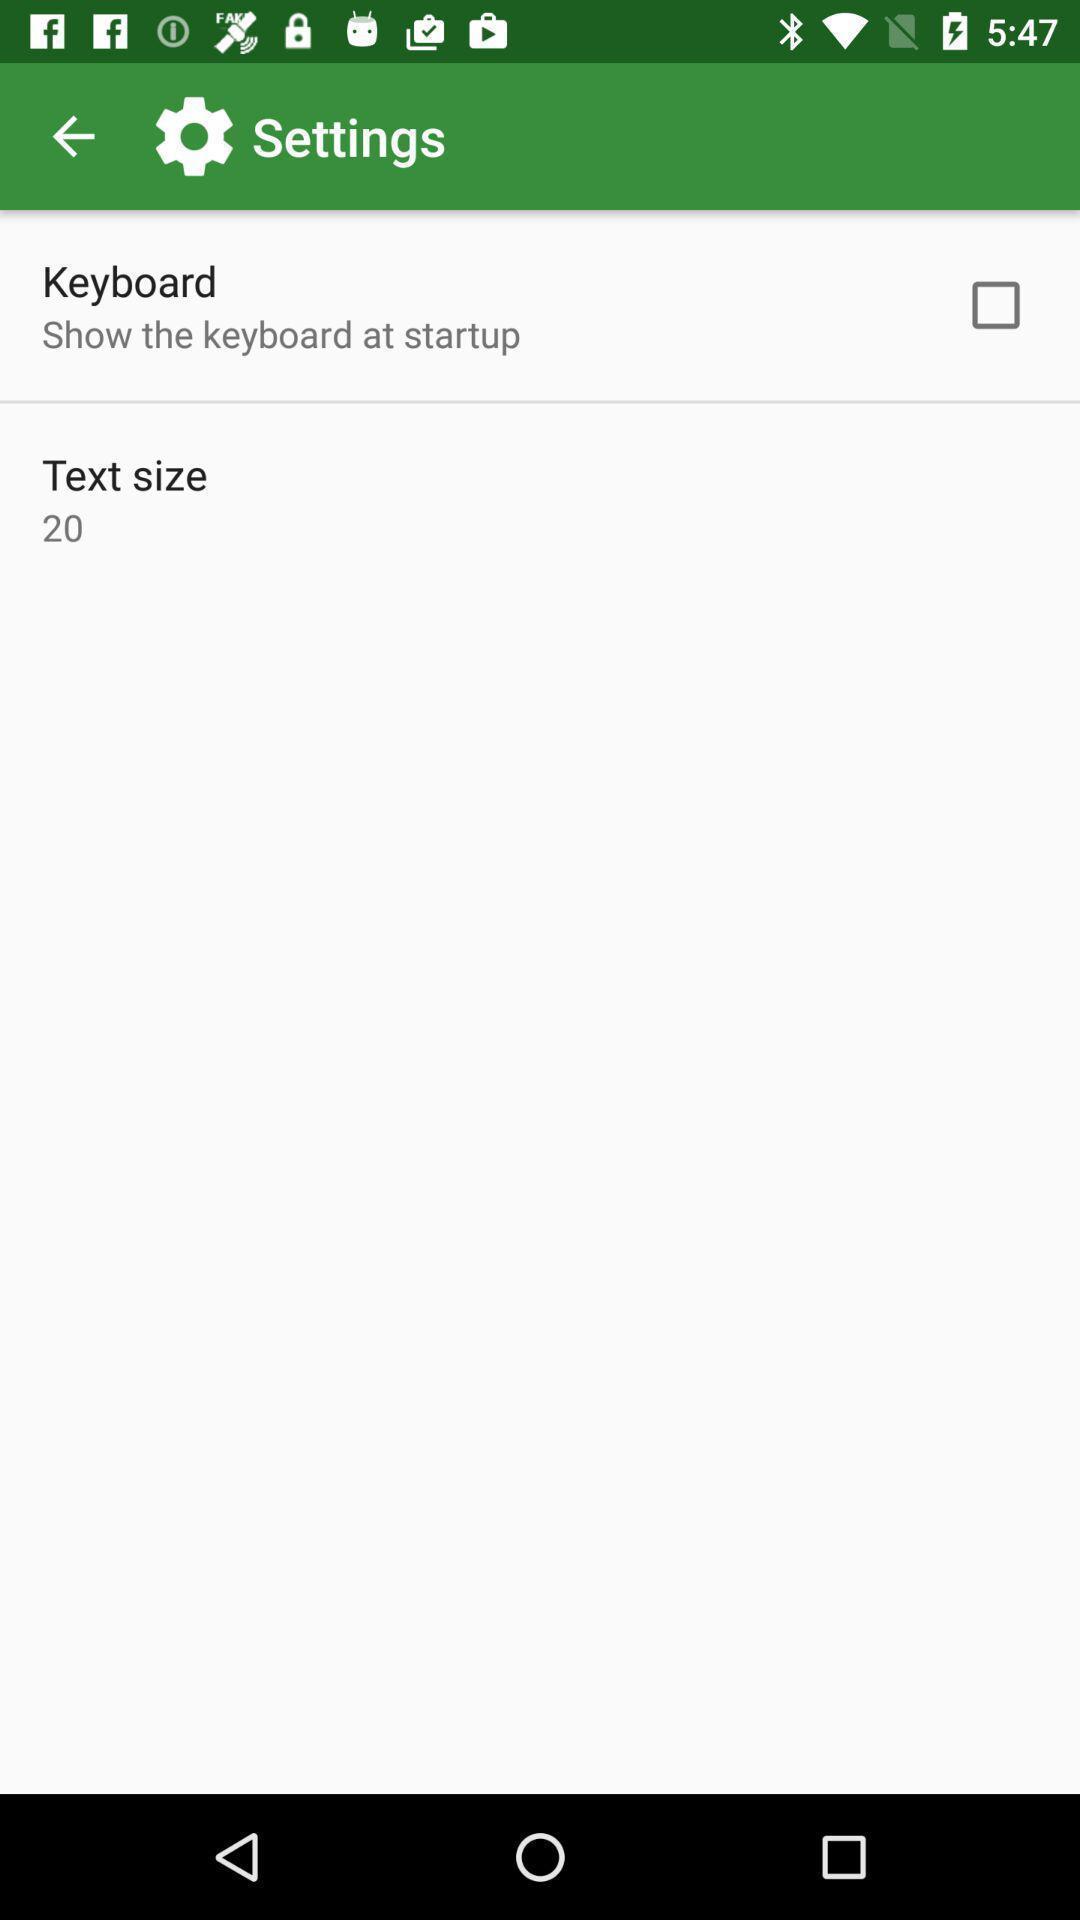What can you discern from this picture? Settings page of translator application. 